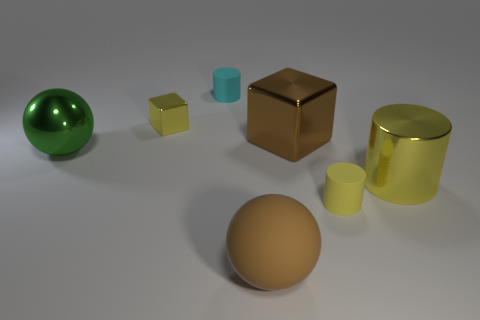Is the number of cubes that are right of the large yellow cylinder greater than the number of objects right of the cyan rubber cylinder?
Make the answer very short. No. Is there another green metal thing that has the same shape as the large green metal thing?
Provide a short and direct response. No. Do the cylinder that is behind the metal sphere and the yellow cube have the same size?
Offer a terse response. Yes. Are there any big blue matte objects?
Your answer should be compact. No. What number of things are yellow things left of the big yellow metal cylinder or small yellow metal things?
Offer a very short reply. 2. There is a shiny ball; does it have the same color as the tiny thing in front of the brown cube?
Offer a terse response. No. Are there any red cylinders that have the same size as the yellow cube?
Your answer should be compact. No. The sphere that is left of the large ball that is right of the yellow cube is made of what material?
Give a very brief answer. Metal. What number of matte cylinders are the same color as the small shiny thing?
Ensure brevity in your answer.  1. What is the shape of the tiny yellow thing that is the same material as the big block?
Keep it short and to the point. Cube. 